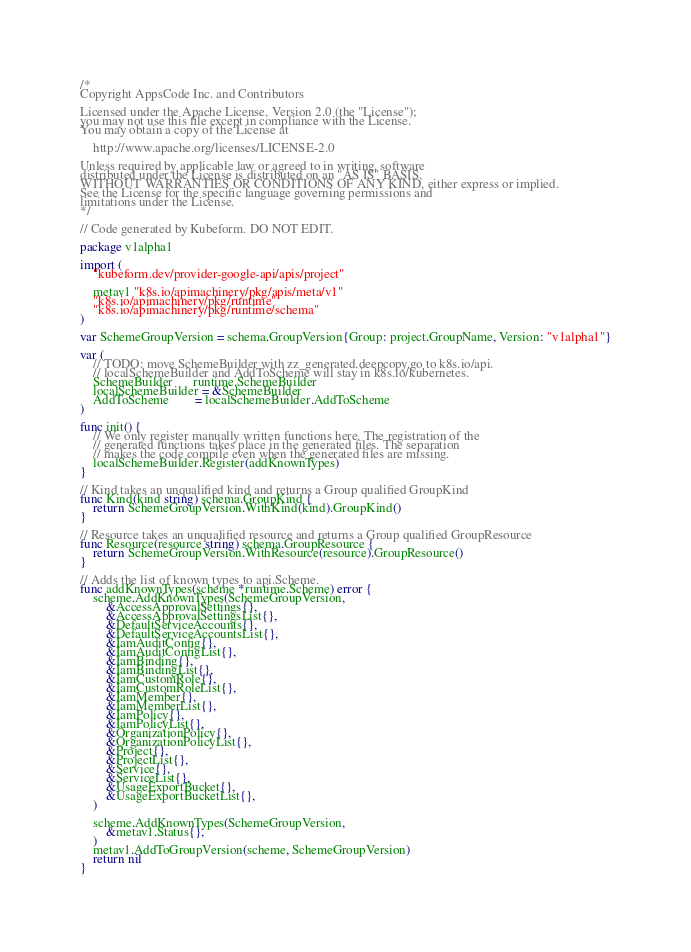<code> <loc_0><loc_0><loc_500><loc_500><_Go_>/*
Copyright AppsCode Inc. and Contributors

Licensed under the Apache License, Version 2.0 (the "License");
you may not use this file except in compliance with the License.
You may obtain a copy of the License at

    http://www.apache.org/licenses/LICENSE-2.0

Unless required by applicable law or agreed to in writing, software
distributed under the License is distributed on an "AS IS" BASIS,
WITHOUT WARRANTIES OR CONDITIONS OF ANY KIND, either express or implied.
See the License for the specific language governing permissions and
limitations under the License.
*/

// Code generated by Kubeform. DO NOT EDIT.

package v1alpha1

import (
	"kubeform.dev/provider-google-api/apis/project"

	metav1 "k8s.io/apimachinery/pkg/apis/meta/v1"
	"k8s.io/apimachinery/pkg/runtime"
	"k8s.io/apimachinery/pkg/runtime/schema"
)

var SchemeGroupVersion = schema.GroupVersion{Group: project.GroupName, Version: "v1alpha1"}

var (
	// TODO: move SchemeBuilder with zz_generated.deepcopy.go to k8s.io/api.
	// localSchemeBuilder and AddToScheme will stay in k8s.io/kubernetes.
	SchemeBuilder      runtime.SchemeBuilder
	localSchemeBuilder = &SchemeBuilder
	AddToScheme        = localSchemeBuilder.AddToScheme
)

func init() {
	// We only register manually written functions here. The registration of the
	// generated functions takes place in the generated files. The separation
	// makes the code compile even when the generated files are missing.
	localSchemeBuilder.Register(addKnownTypes)
}

// Kind takes an unqualified kind and returns a Group qualified GroupKind
func Kind(kind string) schema.GroupKind {
	return SchemeGroupVersion.WithKind(kind).GroupKind()
}

// Resource takes an unqualified resource and returns a Group qualified GroupResource
func Resource(resource string) schema.GroupResource {
	return SchemeGroupVersion.WithResource(resource).GroupResource()
}

// Adds the list of known types to api.Scheme.
func addKnownTypes(scheme *runtime.Scheme) error {
	scheme.AddKnownTypes(SchemeGroupVersion,
		&AccessApprovalSettings{},
		&AccessApprovalSettingsList{},
		&DefaultServiceAccounts{},
		&DefaultServiceAccountsList{},
		&IamAuditConfig{},
		&IamAuditConfigList{},
		&IamBinding{},
		&IamBindingList{},
		&IamCustomRole{},
		&IamCustomRoleList{},
		&IamMember{},
		&IamMemberList{},
		&IamPolicy{},
		&IamPolicyList{},
		&OrganizationPolicy{},
		&OrganizationPolicyList{},
		&Project{},
		&ProjectList{},
		&Service{},
		&ServiceList{},
		&UsageExportBucket{},
		&UsageExportBucketList{},
	)

	scheme.AddKnownTypes(SchemeGroupVersion,
		&metav1.Status{},
	)
	metav1.AddToGroupVersion(scheme, SchemeGroupVersion)
	return nil
}
</code> 